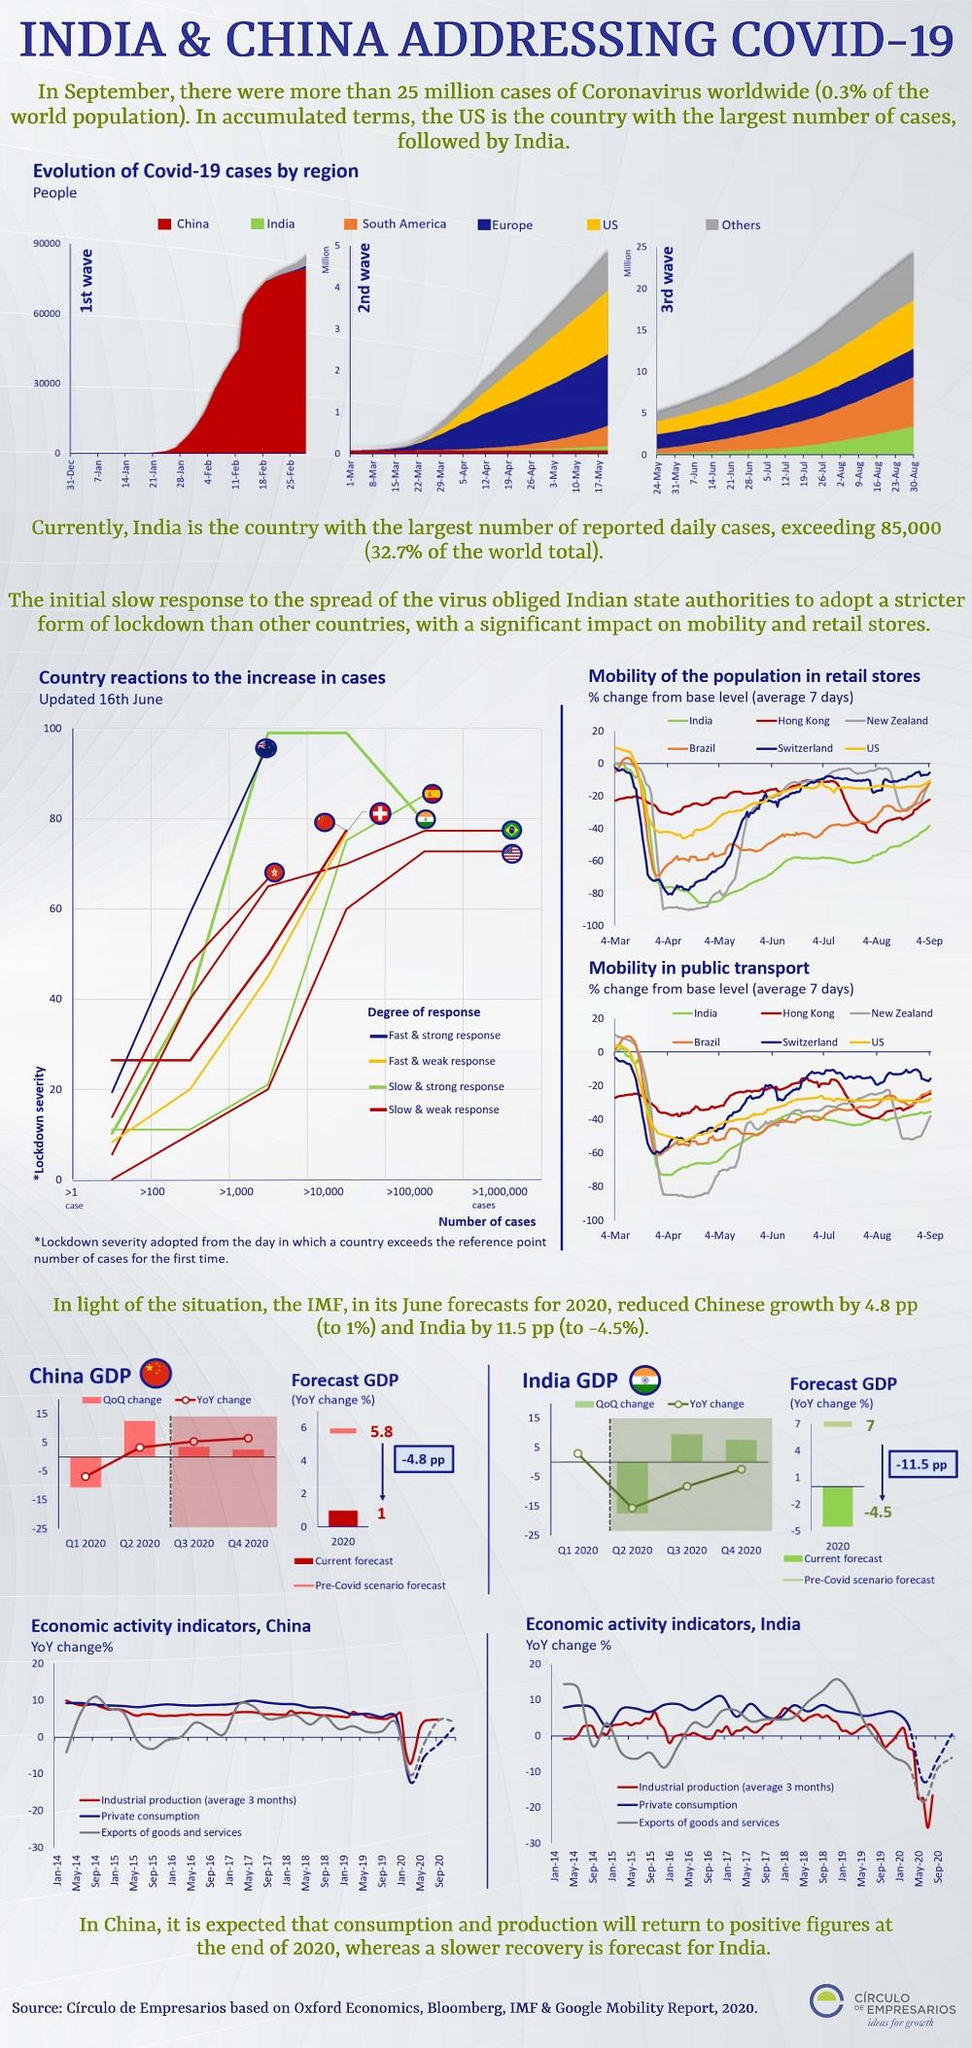Indicate a few pertinent items in this graphic. India has a slow but strong degree of response, making it the correct choice among the options of America, China, Australia, and India. The country with a slow and weak degree of response is America. This is evident in the comparison of America to other countries, such as China, Australia, and India, which are known for their faster and more robust responses. Therefore, it can be concluded that America has a slower and weaker response than these other countries. Australia has a fast and strong degree of response. The color red is used to represent china-yellow, orange, and red in the RGB color model. 